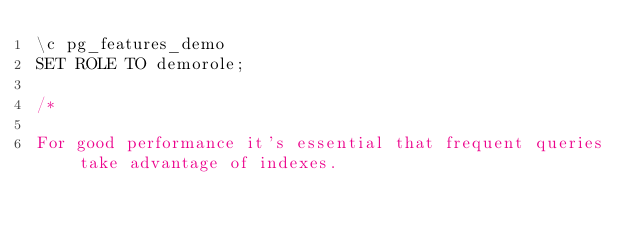<code> <loc_0><loc_0><loc_500><loc_500><_SQL_>\c pg_features_demo
SET ROLE TO demorole;

/*

For good performance it's essential that frequent queries take advantage of indexes.</code> 